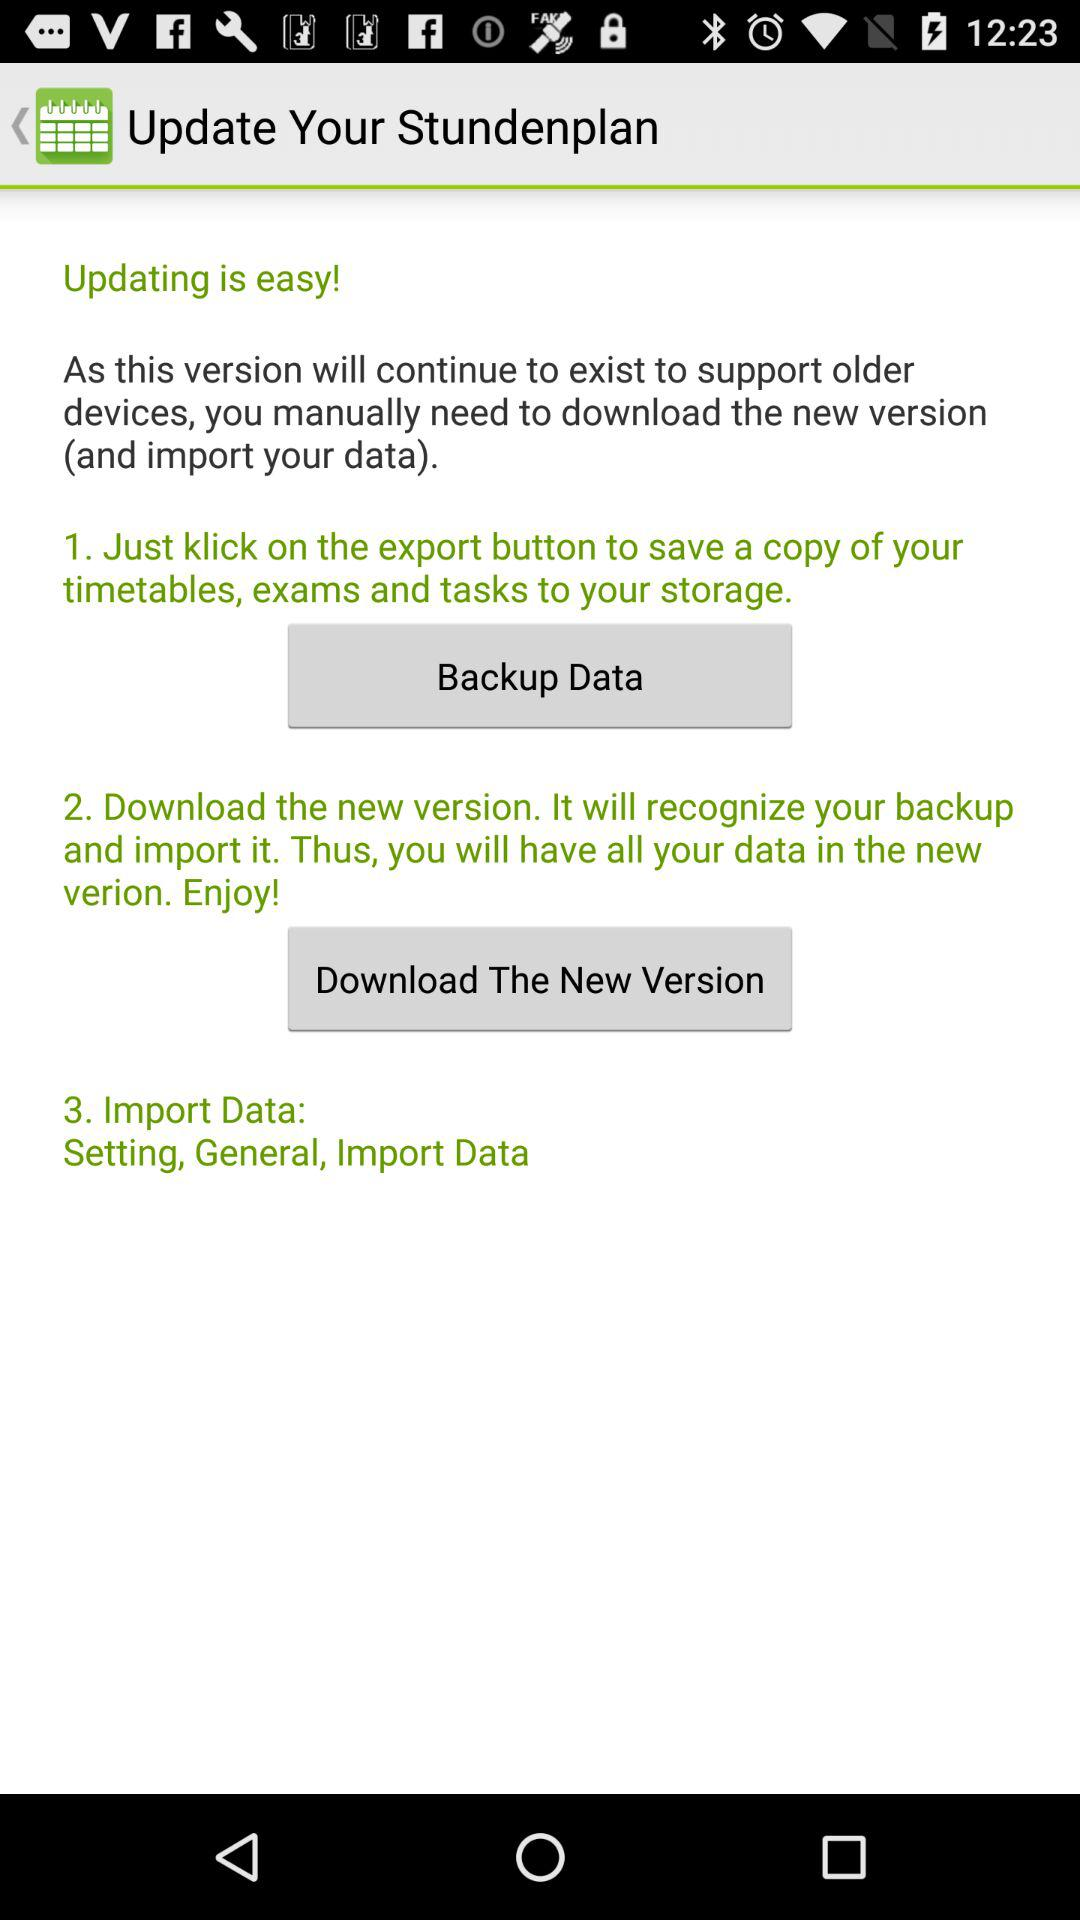How many steps are there in the update process?
Answer the question using a single word or phrase. 3 